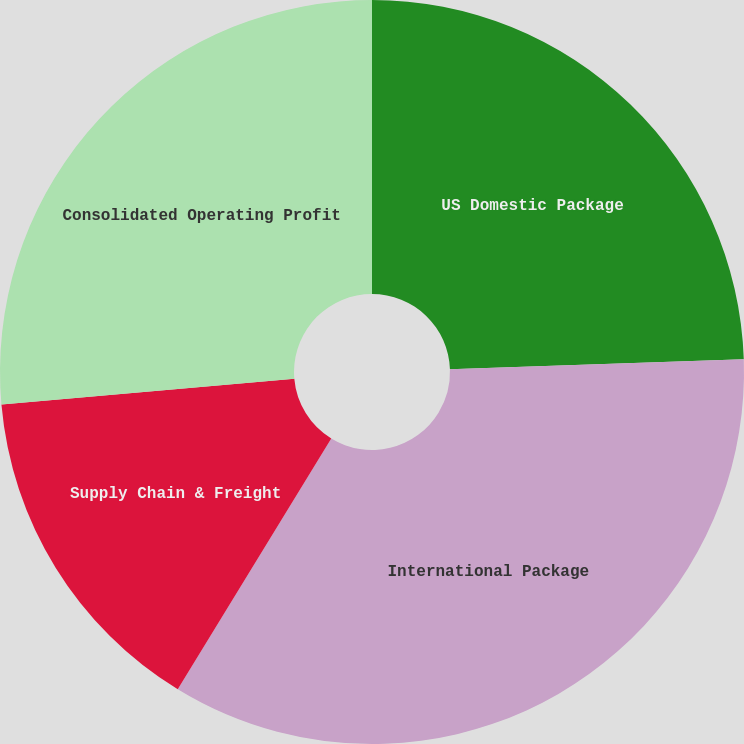Convert chart to OTSL. <chart><loc_0><loc_0><loc_500><loc_500><pie_chart><fcel>US Domestic Package<fcel>International Package<fcel>Supply Chain & Freight<fcel>Consolidated Operating Profit<nl><fcel>24.46%<fcel>34.29%<fcel>14.86%<fcel>26.4%<nl></chart> 